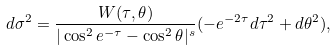<formula> <loc_0><loc_0><loc_500><loc_500>d \sigma ^ { 2 } = \frac { W ( \tau , \theta ) } { | \cos ^ { 2 } e ^ { - \tau } - \cos ^ { 2 } \theta | ^ { s } } ( - e ^ { - 2 \tau } d \tau ^ { 2 } + d \theta ^ { 2 } ) ,</formula> 